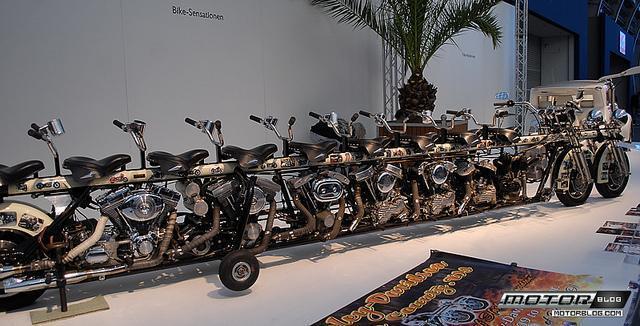How many motorcycles are in the photo?
Give a very brief answer. 9. 